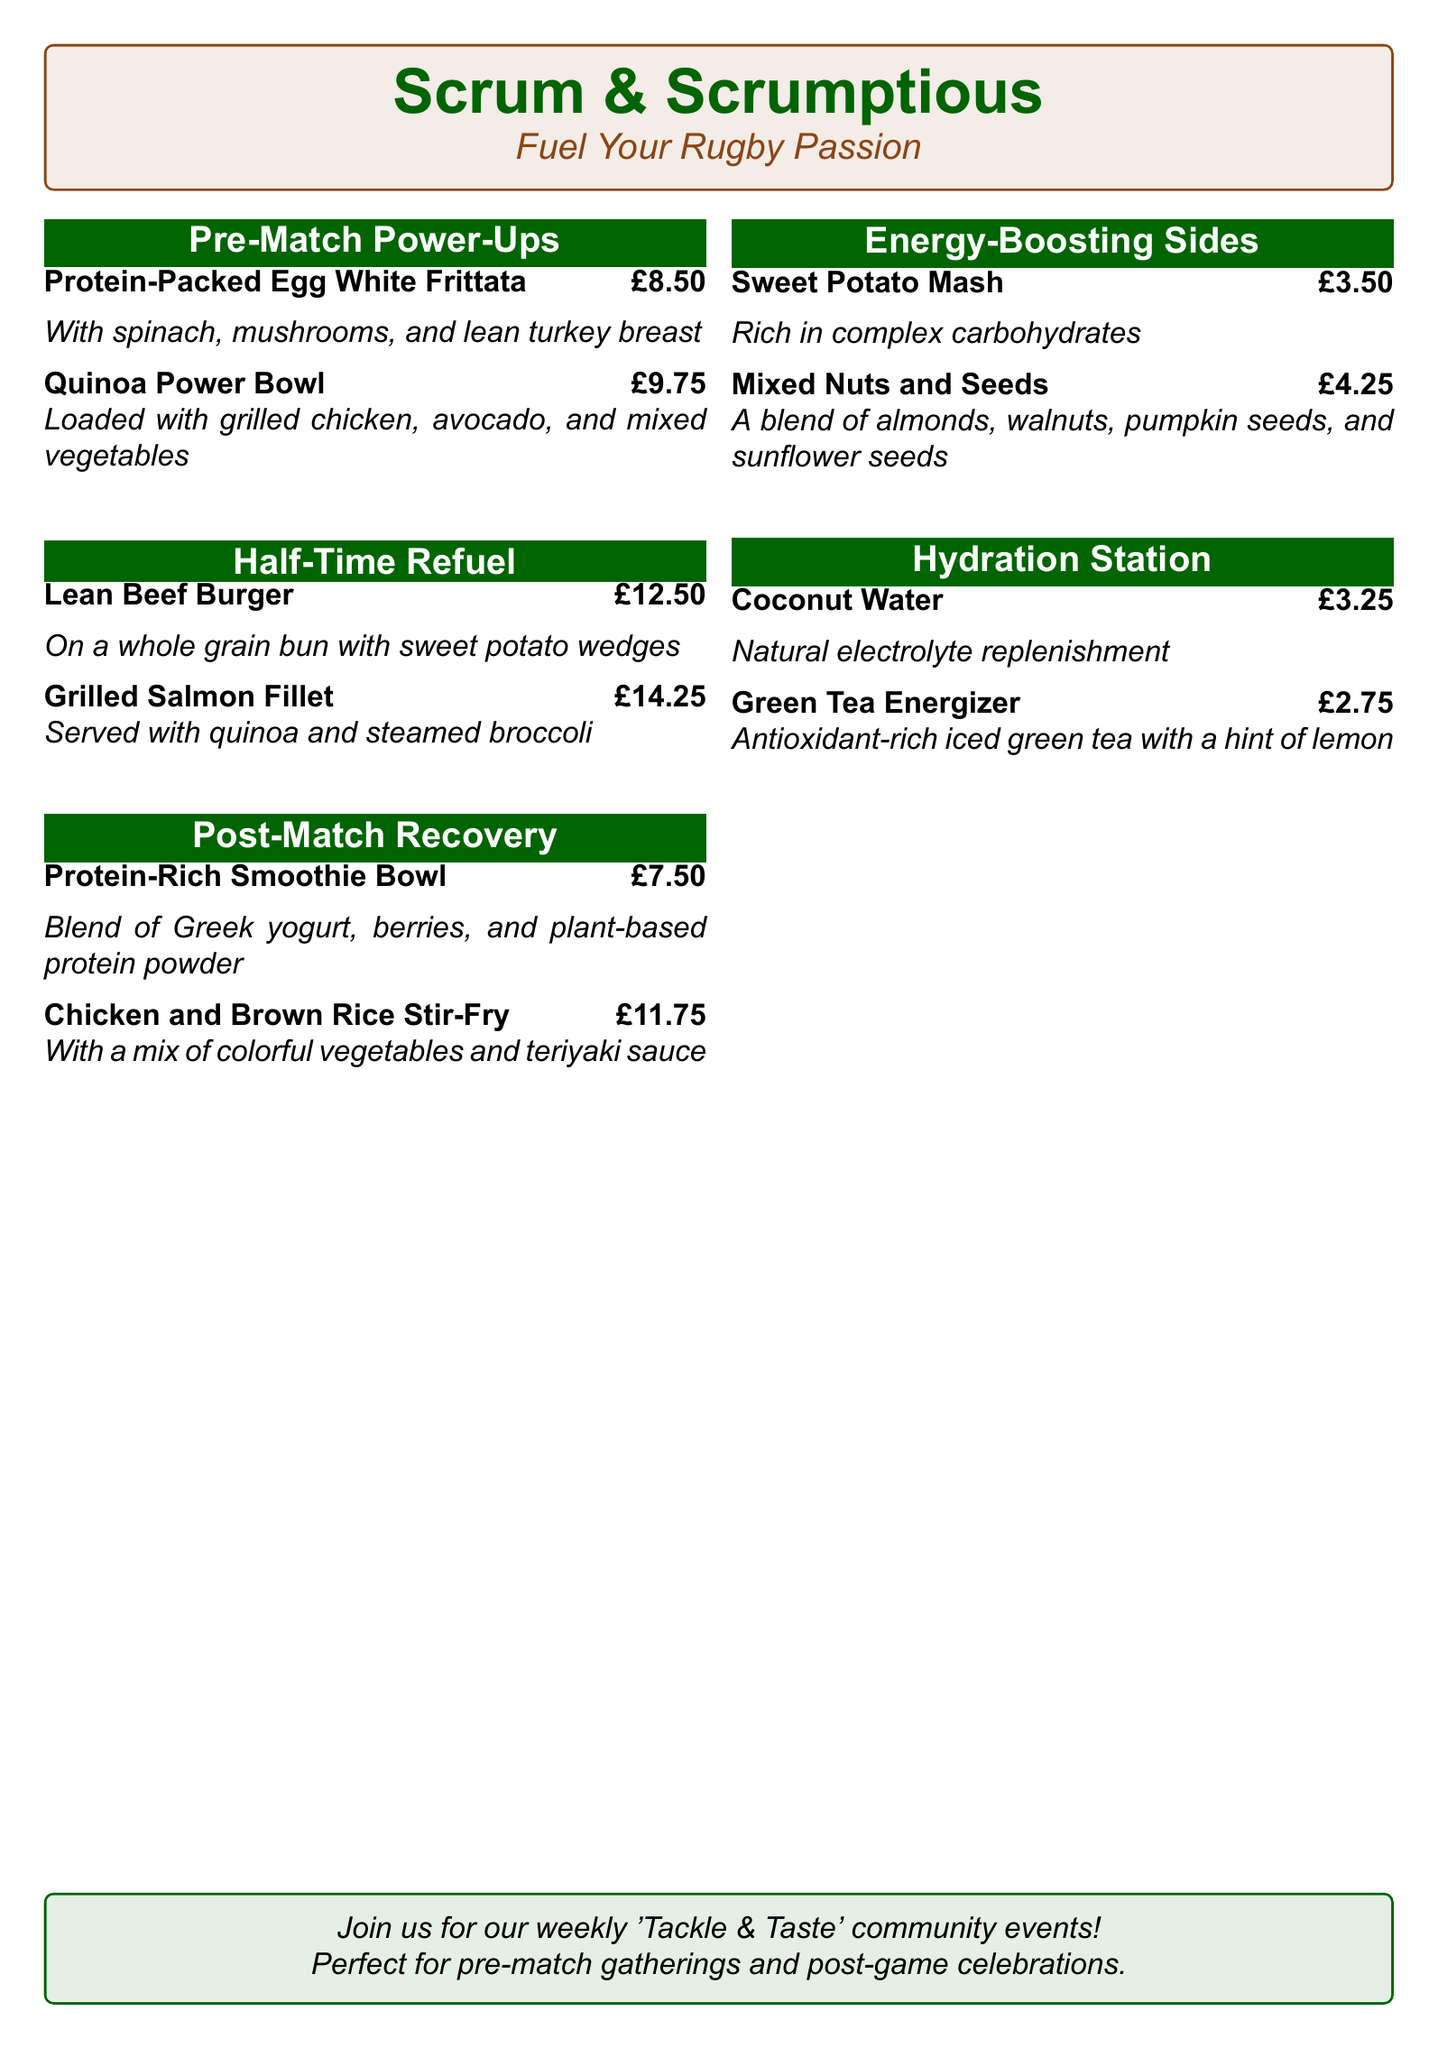What is the name of the restaurant? The name of the restaurant is displayed prominently at the top of the menu document.
Answer: Scrum & Scrumptious What is the price of the Protein-Packed Egg White Frittata? The price is mentioned next to the dish in the menu section.
Answer: £8.50 Which dish comes with sweet potato wedges? This refers to a specific dish listed in the menu that includes sweet potato wedges as a side.
Answer: Lean Beef Burger What type of beverage is offered as a Hydration Station option? The menu lists specific types of drinks available under the Hydration Station section.
Answer: Coconut Water What ingredient is used in the Chicken and Brown Rice Stir-Fry? Identifying the main components of the dish mentioned in the description helps answer this question.
Answer: Colorful vegetables How much does the Grilled Salmon Fillet cost? The cost of this dish is specified in the menu document.
Answer: £14.25 Which section features energy-boosting sides? This section title provides insight into the types of items available on the menu focused on energy.
Answer: Energy-Boosting Sides What community event is mentioned in the document? This question refers to an event specifically designed for the restaurant's community engagement.
Answer: Tackle & Taste How many dishes are included in the Half-Time Refuel section? The number of dishes is determined by counting the items in the specified section of the menu.
Answer: 2 